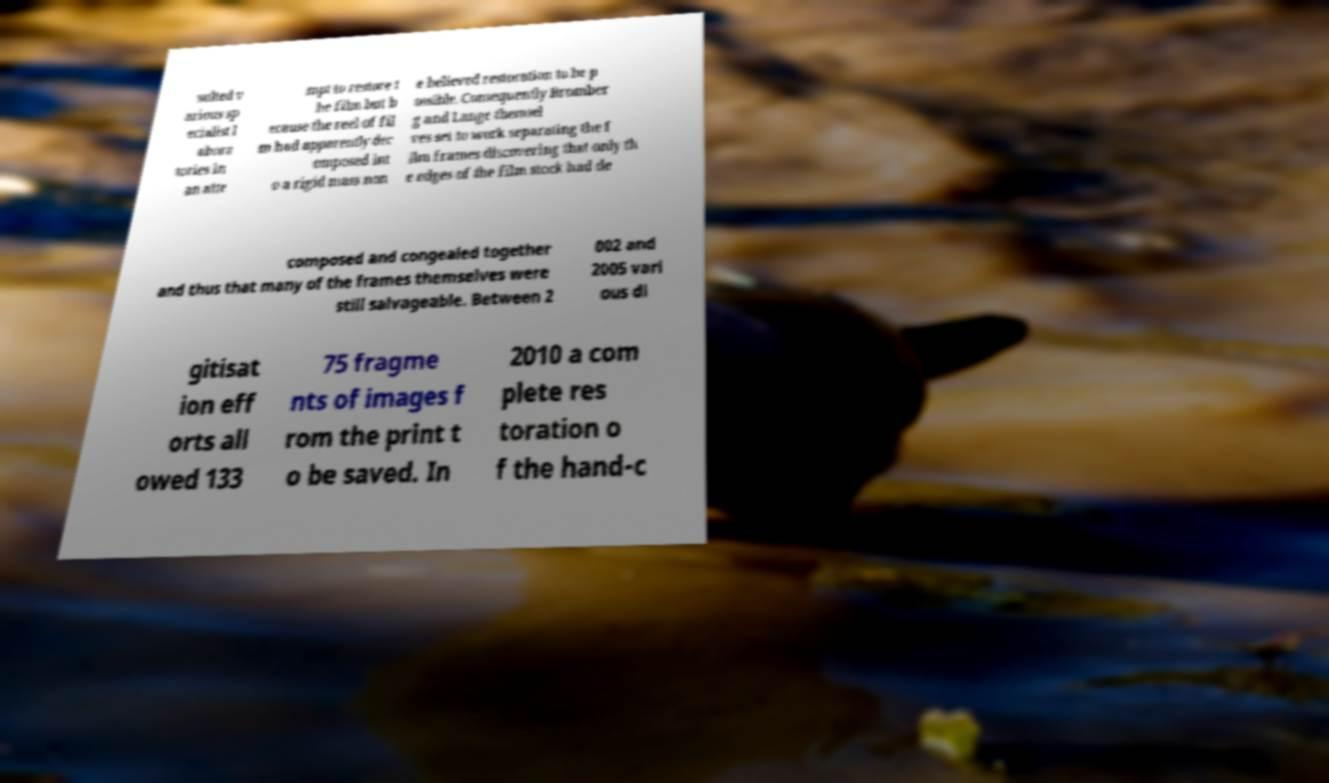Can you read and provide the text displayed in the image?This photo seems to have some interesting text. Can you extract and type it out for me? sulted v arious sp ecialist l abora tories in an atte mpt to restore t he film but b ecause the reel of fil m had apparently dec omposed int o a rigid mass non e believed restoration to be p ossible. Consequently Bromber g and Lange themsel ves set to work separating the f ilm frames discovering that only th e edges of the film stock had de composed and congealed together and thus that many of the frames themselves were still salvageable. Between 2 002 and 2005 vari ous di gitisat ion eff orts all owed 133 75 fragme nts of images f rom the print t o be saved. In 2010 a com plete res toration o f the hand-c 